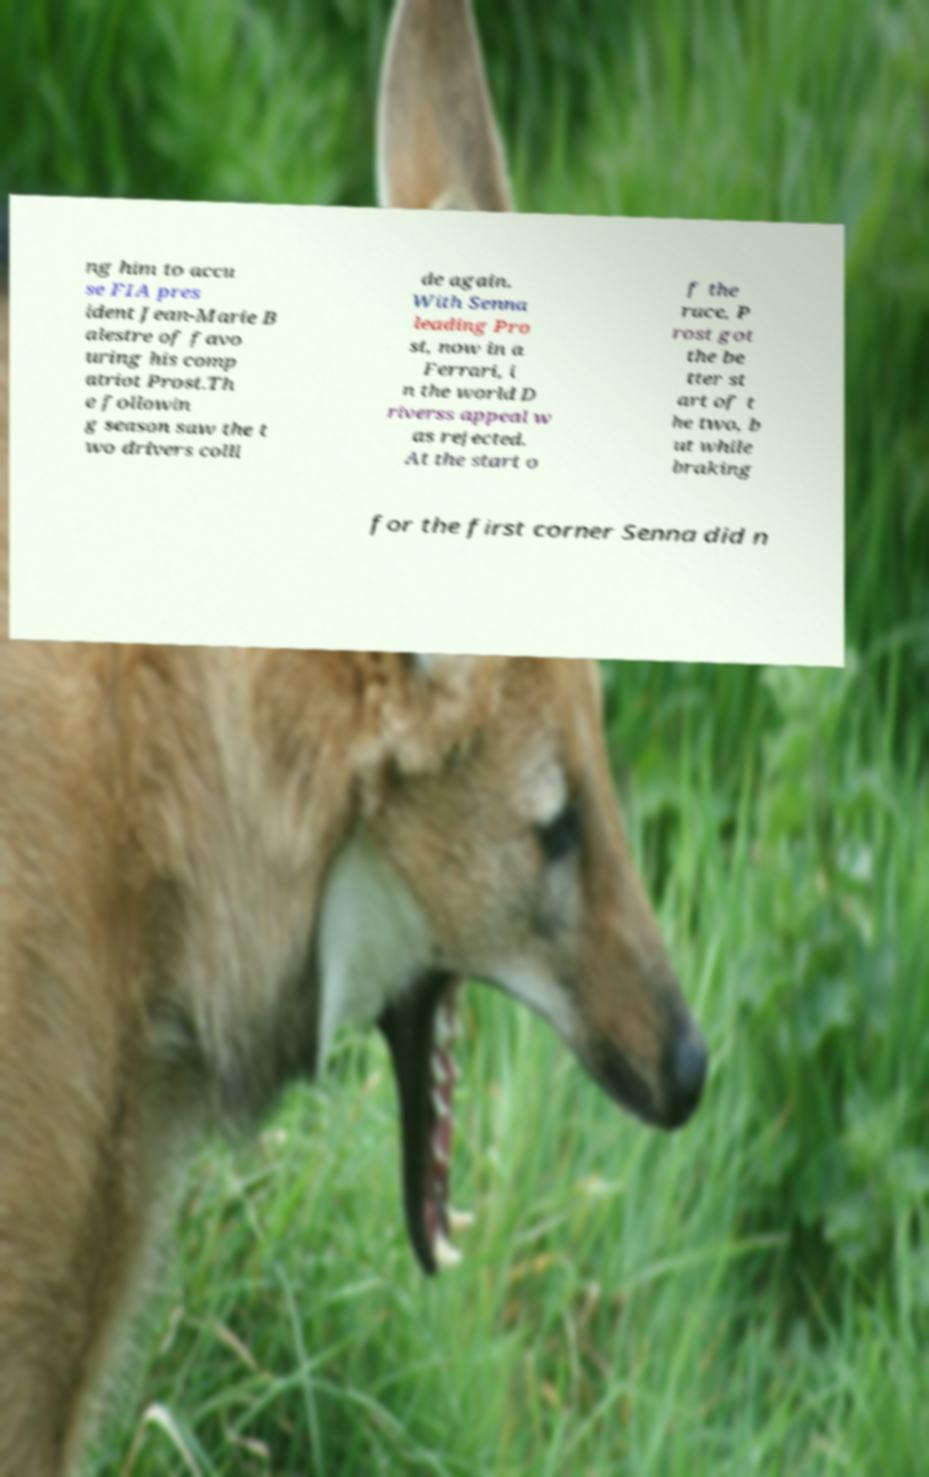Please identify and transcribe the text found in this image. ng him to accu se FIA pres ident Jean-Marie B alestre of favo uring his comp atriot Prost.Th e followin g season saw the t wo drivers colli de again. With Senna leading Pro st, now in a Ferrari, i n the world D riverss appeal w as rejected. At the start o f the race, P rost got the be tter st art of t he two, b ut while braking for the first corner Senna did n 